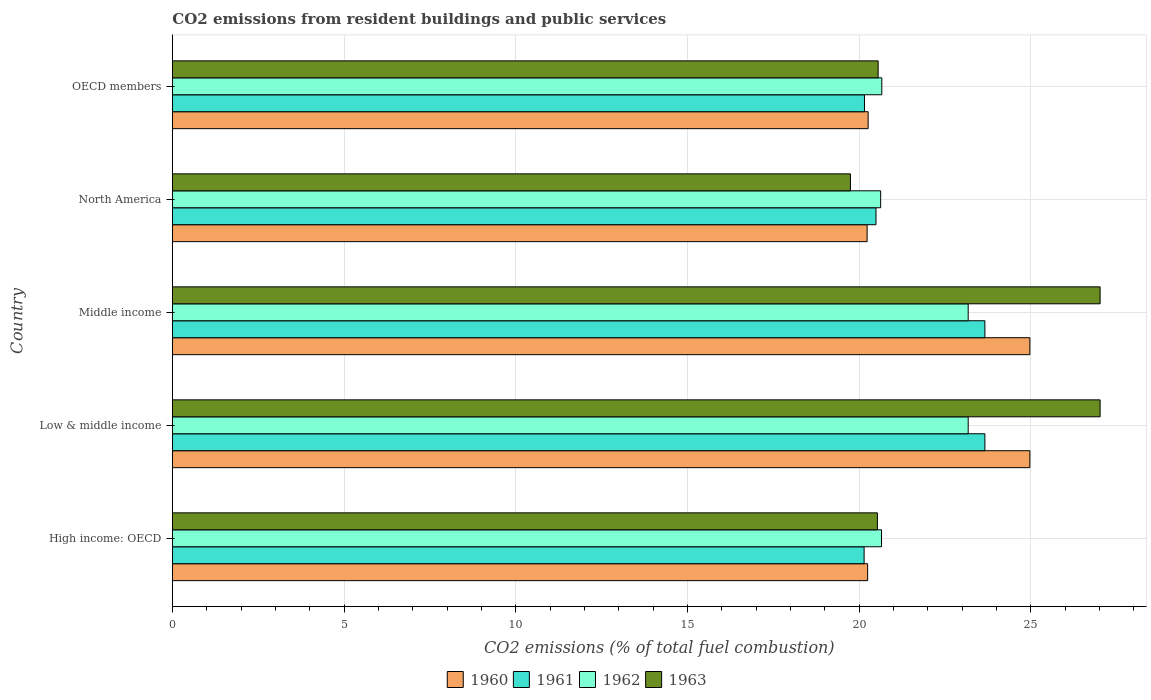Are the number of bars on each tick of the Y-axis equal?
Your answer should be compact. Yes. How many bars are there on the 5th tick from the top?
Offer a very short reply. 4. How many bars are there on the 1st tick from the bottom?
Your answer should be compact. 4. What is the total CO2 emitted in 1962 in OECD members?
Provide a succinct answer. 20.66. Across all countries, what is the maximum total CO2 emitted in 1962?
Provide a succinct answer. 23.17. Across all countries, what is the minimum total CO2 emitted in 1963?
Provide a short and direct response. 19.74. In which country was the total CO2 emitted in 1962 maximum?
Your answer should be compact. Low & middle income. What is the total total CO2 emitted in 1960 in the graph?
Provide a succinct answer. 110.68. What is the difference between the total CO2 emitted in 1962 in Low & middle income and that in North America?
Provide a short and direct response. 2.55. What is the difference between the total CO2 emitted in 1960 in High income: OECD and the total CO2 emitted in 1961 in Low & middle income?
Your response must be concise. -3.41. What is the average total CO2 emitted in 1963 per country?
Your answer should be compact. 22.97. What is the difference between the total CO2 emitted in 1963 and total CO2 emitted in 1960 in OECD members?
Give a very brief answer. 0.29. What is the ratio of the total CO2 emitted in 1961 in North America to that in OECD members?
Ensure brevity in your answer.  1.02. Is the total CO2 emitted in 1960 in High income: OECD less than that in Middle income?
Your response must be concise. Yes. What is the difference between the highest and the second highest total CO2 emitted in 1962?
Make the answer very short. 0. What is the difference between the highest and the lowest total CO2 emitted in 1961?
Your answer should be very brief. 3.52. In how many countries, is the total CO2 emitted in 1962 greater than the average total CO2 emitted in 1962 taken over all countries?
Provide a succinct answer. 2. What does the 1st bar from the top in OECD members represents?
Provide a succinct answer. 1963. How many bars are there?
Provide a short and direct response. 20. Are all the bars in the graph horizontal?
Your answer should be very brief. Yes. Are the values on the major ticks of X-axis written in scientific E-notation?
Make the answer very short. No. Does the graph contain any zero values?
Give a very brief answer. No. Where does the legend appear in the graph?
Your answer should be compact. Bottom center. How are the legend labels stacked?
Your answer should be very brief. Horizontal. What is the title of the graph?
Your answer should be very brief. CO2 emissions from resident buildings and public services. Does "1994" appear as one of the legend labels in the graph?
Offer a terse response. No. What is the label or title of the X-axis?
Your answer should be very brief. CO2 emissions (% of total fuel combustion). What is the label or title of the Y-axis?
Offer a terse response. Country. What is the CO2 emissions (% of total fuel combustion) in 1960 in High income: OECD?
Provide a short and direct response. 20.25. What is the CO2 emissions (% of total fuel combustion) of 1961 in High income: OECD?
Your answer should be very brief. 20.14. What is the CO2 emissions (% of total fuel combustion) of 1962 in High income: OECD?
Keep it short and to the point. 20.65. What is the CO2 emissions (% of total fuel combustion) of 1963 in High income: OECD?
Offer a very short reply. 20.53. What is the CO2 emissions (% of total fuel combustion) in 1960 in Low & middle income?
Make the answer very short. 24.97. What is the CO2 emissions (% of total fuel combustion) of 1961 in Low & middle income?
Your answer should be compact. 23.66. What is the CO2 emissions (% of total fuel combustion) of 1962 in Low & middle income?
Your response must be concise. 23.17. What is the CO2 emissions (% of total fuel combustion) of 1963 in Low & middle income?
Your response must be concise. 27.01. What is the CO2 emissions (% of total fuel combustion) of 1960 in Middle income?
Your answer should be compact. 24.97. What is the CO2 emissions (% of total fuel combustion) of 1961 in Middle income?
Your answer should be compact. 23.66. What is the CO2 emissions (% of total fuel combustion) of 1962 in Middle income?
Ensure brevity in your answer.  23.17. What is the CO2 emissions (% of total fuel combustion) of 1963 in Middle income?
Provide a succinct answer. 27.01. What is the CO2 emissions (% of total fuel combustion) of 1960 in North America?
Ensure brevity in your answer.  20.23. What is the CO2 emissions (% of total fuel combustion) in 1961 in North America?
Offer a terse response. 20.49. What is the CO2 emissions (% of total fuel combustion) of 1962 in North America?
Provide a short and direct response. 20.62. What is the CO2 emissions (% of total fuel combustion) in 1963 in North America?
Give a very brief answer. 19.74. What is the CO2 emissions (% of total fuel combustion) of 1960 in OECD members?
Make the answer very short. 20.26. What is the CO2 emissions (% of total fuel combustion) in 1961 in OECD members?
Your response must be concise. 20.15. What is the CO2 emissions (% of total fuel combustion) of 1962 in OECD members?
Your answer should be very brief. 20.66. What is the CO2 emissions (% of total fuel combustion) of 1963 in OECD members?
Your response must be concise. 20.55. Across all countries, what is the maximum CO2 emissions (% of total fuel combustion) of 1960?
Your response must be concise. 24.97. Across all countries, what is the maximum CO2 emissions (% of total fuel combustion) of 1961?
Provide a short and direct response. 23.66. Across all countries, what is the maximum CO2 emissions (% of total fuel combustion) of 1962?
Your response must be concise. 23.17. Across all countries, what is the maximum CO2 emissions (% of total fuel combustion) of 1963?
Your response must be concise. 27.01. Across all countries, what is the minimum CO2 emissions (% of total fuel combustion) in 1960?
Provide a succinct answer. 20.23. Across all countries, what is the minimum CO2 emissions (% of total fuel combustion) of 1961?
Your answer should be compact. 20.14. Across all countries, what is the minimum CO2 emissions (% of total fuel combustion) in 1962?
Ensure brevity in your answer.  20.62. Across all countries, what is the minimum CO2 emissions (% of total fuel combustion) of 1963?
Your answer should be very brief. 19.74. What is the total CO2 emissions (% of total fuel combustion) of 1960 in the graph?
Provide a succinct answer. 110.68. What is the total CO2 emissions (% of total fuel combustion) in 1961 in the graph?
Your answer should be compact. 108.11. What is the total CO2 emissions (% of total fuel combustion) in 1962 in the graph?
Make the answer very short. 108.28. What is the total CO2 emissions (% of total fuel combustion) in 1963 in the graph?
Your answer should be very brief. 114.86. What is the difference between the CO2 emissions (% of total fuel combustion) in 1960 in High income: OECD and that in Low & middle income?
Offer a terse response. -4.72. What is the difference between the CO2 emissions (% of total fuel combustion) in 1961 in High income: OECD and that in Low & middle income?
Your response must be concise. -3.52. What is the difference between the CO2 emissions (% of total fuel combustion) in 1962 in High income: OECD and that in Low & middle income?
Give a very brief answer. -2.52. What is the difference between the CO2 emissions (% of total fuel combustion) of 1963 in High income: OECD and that in Low & middle income?
Provide a succinct answer. -6.48. What is the difference between the CO2 emissions (% of total fuel combustion) in 1960 in High income: OECD and that in Middle income?
Make the answer very short. -4.72. What is the difference between the CO2 emissions (% of total fuel combustion) in 1961 in High income: OECD and that in Middle income?
Offer a terse response. -3.52. What is the difference between the CO2 emissions (% of total fuel combustion) in 1962 in High income: OECD and that in Middle income?
Ensure brevity in your answer.  -2.52. What is the difference between the CO2 emissions (% of total fuel combustion) of 1963 in High income: OECD and that in Middle income?
Offer a terse response. -6.48. What is the difference between the CO2 emissions (% of total fuel combustion) of 1960 in High income: OECD and that in North America?
Ensure brevity in your answer.  0.01. What is the difference between the CO2 emissions (% of total fuel combustion) in 1961 in High income: OECD and that in North America?
Provide a succinct answer. -0.35. What is the difference between the CO2 emissions (% of total fuel combustion) of 1962 in High income: OECD and that in North America?
Make the answer very short. 0.03. What is the difference between the CO2 emissions (% of total fuel combustion) in 1963 in High income: OECD and that in North America?
Offer a very short reply. 0.79. What is the difference between the CO2 emissions (% of total fuel combustion) of 1960 in High income: OECD and that in OECD members?
Your answer should be very brief. -0.01. What is the difference between the CO2 emissions (% of total fuel combustion) in 1961 in High income: OECD and that in OECD members?
Your answer should be very brief. -0.01. What is the difference between the CO2 emissions (% of total fuel combustion) in 1962 in High income: OECD and that in OECD members?
Keep it short and to the point. -0.01. What is the difference between the CO2 emissions (% of total fuel combustion) of 1963 in High income: OECD and that in OECD members?
Offer a terse response. -0.02. What is the difference between the CO2 emissions (% of total fuel combustion) in 1961 in Low & middle income and that in Middle income?
Ensure brevity in your answer.  0. What is the difference between the CO2 emissions (% of total fuel combustion) of 1962 in Low & middle income and that in Middle income?
Provide a short and direct response. 0. What is the difference between the CO2 emissions (% of total fuel combustion) in 1963 in Low & middle income and that in Middle income?
Offer a very short reply. 0. What is the difference between the CO2 emissions (% of total fuel combustion) of 1960 in Low & middle income and that in North America?
Offer a terse response. 4.74. What is the difference between the CO2 emissions (% of total fuel combustion) in 1961 in Low & middle income and that in North America?
Offer a terse response. 3.17. What is the difference between the CO2 emissions (% of total fuel combustion) in 1962 in Low & middle income and that in North America?
Offer a terse response. 2.55. What is the difference between the CO2 emissions (% of total fuel combustion) in 1963 in Low & middle income and that in North America?
Offer a very short reply. 7.27. What is the difference between the CO2 emissions (% of total fuel combustion) in 1960 in Low & middle income and that in OECD members?
Make the answer very short. 4.71. What is the difference between the CO2 emissions (% of total fuel combustion) of 1961 in Low & middle income and that in OECD members?
Your answer should be compact. 3.51. What is the difference between the CO2 emissions (% of total fuel combustion) of 1962 in Low & middle income and that in OECD members?
Offer a very short reply. 2.52. What is the difference between the CO2 emissions (% of total fuel combustion) of 1963 in Low & middle income and that in OECD members?
Offer a terse response. 6.46. What is the difference between the CO2 emissions (% of total fuel combustion) in 1960 in Middle income and that in North America?
Ensure brevity in your answer.  4.74. What is the difference between the CO2 emissions (% of total fuel combustion) in 1961 in Middle income and that in North America?
Make the answer very short. 3.17. What is the difference between the CO2 emissions (% of total fuel combustion) of 1962 in Middle income and that in North America?
Keep it short and to the point. 2.55. What is the difference between the CO2 emissions (% of total fuel combustion) of 1963 in Middle income and that in North America?
Give a very brief answer. 7.27. What is the difference between the CO2 emissions (% of total fuel combustion) of 1960 in Middle income and that in OECD members?
Your answer should be compact. 4.71. What is the difference between the CO2 emissions (% of total fuel combustion) in 1961 in Middle income and that in OECD members?
Keep it short and to the point. 3.51. What is the difference between the CO2 emissions (% of total fuel combustion) in 1962 in Middle income and that in OECD members?
Your answer should be compact. 2.52. What is the difference between the CO2 emissions (% of total fuel combustion) in 1963 in Middle income and that in OECD members?
Keep it short and to the point. 6.46. What is the difference between the CO2 emissions (% of total fuel combustion) of 1960 in North America and that in OECD members?
Ensure brevity in your answer.  -0.03. What is the difference between the CO2 emissions (% of total fuel combustion) of 1961 in North America and that in OECD members?
Your answer should be very brief. 0.34. What is the difference between the CO2 emissions (% of total fuel combustion) of 1962 in North America and that in OECD members?
Your answer should be compact. -0.03. What is the difference between the CO2 emissions (% of total fuel combustion) in 1963 in North America and that in OECD members?
Provide a short and direct response. -0.81. What is the difference between the CO2 emissions (% of total fuel combustion) of 1960 in High income: OECD and the CO2 emissions (% of total fuel combustion) of 1961 in Low & middle income?
Provide a succinct answer. -3.41. What is the difference between the CO2 emissions (% of total fuel combustion) of 1960 in High income: OECD and the CO2 emissions (% of total fuel combustion) of 1962 in Low & middle income?
Give a very brief answer. -2.93. What is the difference between the CO2 emissions (% of total fuel combustion) in 1960 in High income: OECD and the CO2 emissions (% of total fuel combustion) in 1963 in Low & middle income?
Your response must be concise. -6.77. What is the difference between the CO2 emissions (% of total fuel combustion) of 1961 in High income: OECD and the CO2 emissions (% of total fuel combustion) of 1962 in Low & middle income?
Provide a short and direct response. -3.03. What is the difference between the CO2 emissions (% of total fuel combustion) of 1961 in High income: OECD and the CO2 emissions (% of total fuel combustion) of 1963 in Low & middle income?
Your answer should be very brief. -6.87. What is the difference between the CO2 emissions (% of total fuel combustion) of 1962 in High income: OECD and the CO2 emissions (% of total fuel combustion) of 1963 in Low & middle income?
Your answer should be compact. -6.36. What is the difference between the CO2 emissions (% of total fuel combustion) in 1960 in High income: OECD and the CO2 emissions (% of total fuel combustion) in 1961 in Middle income?
Offer a terse response. -3.41. What is the difference between the CO2 emissions (% of total fuel combustion) of 1960 in High income: OECD and the CO2 emissions (% of total fuel combustion) of 1962 in Middle income?
Ensure brevity in your answer.  -2.93. What is the difference between the CO2 emissions (% of total fuel combustion) in 1960 in High income: OECD and the CO2 emissions (% of total fuel combustion) in 1963 in Middle income?
Offer a very short reply. -6.77. What is the difference between the CO2 emissions (% of total fuel combustion) of 1961 in High income: OECD and the CO2 emissions (% of total fuel combustion) of 1962 in Middle income?
Your response must be concise. -3.03. What is the difference between the CO2 emissions (% of total fuel combustion) in 1961 in High income: OECD and the CO2 emissions (% of total fuel combustion) in 1963 in Middle income?
Offer a terse response. -6.87. What is the difference between the CO2 emissions (% of total fuel combustion) of 1962 in High income: OECD and the CO2 emissions (% of total fuel combustion) of 1963 in Middle income?
Your response must be concise. -6.36. What is the difference between the CO2 emissions (% of total fuel combustion) of 1960 in High income: OECD and the CO2 emissions (% of total fuel combustion) of 1961 in North America?
Give a very brief answer. -0.24. What is the difference between the CO2 emissions (% of total fuel combustion) of 1960 in High income: OECD and the CO2 emissions (% of total fuel combustion) of 1962 in North America?
Your answer should be very brief. -0.38. What is the difference between the CO2 emissions (% of total fuel combustion) of 1960 in High income: OECD and the CO2 emissions (% of total fuel combustion) of 1963 in North America?
Offer a terse response. 0.5. What is the difference between the CO2 emissions (% of total fuel combustion) in 1961 in High income: OECD and the CO2 emissions (% of total fuel combustion) in 1962 in North America?
Ensure brevity in your answer.  -0.48. What is the difference between the CO2 emissions (% of total fuel combustion) of 1961 in High income: OECD and the CO2 emissions (% of total fuel combustion) of 1963 in North America?
Provide a short and direct response. 0.4. What is the difference between the CO2 emissions (% of total fuel combustion) in 1962 in High income: OECD and the CO2 emissions (% of total fuel combustion) in 1963 in North America?
Your answer should be compact. 0.91. What is the difference between the CO2 emissions (% of total fuel combustion) in 1960 in High income: OECD and the CO2 emissions (% of total fuel combustion) in 1961 in OECD members?
Provide a succinct answer. 0.09. What is the difference between the CO2 emissions (% of total fuel combustion) in 1960 in High income: OECD and the CO2 emissions (% of total fuel combustion) in 1962 in OECD members?
Offer a very short reply. -0.41. What is the difference between the CO2 emissions (% of total fuel combustion) of 1960 in High income: OECD and the CO2 emissions (% of total fuel combustion) of 1963 in OECD members?
Offer a very short reply. -0.31. What is the difference between the CO2 emissions (% of total fuel combustion) of 1961 in High income: OECD and the CO2 emissions (% of total fuel combustion) of 1962 in OECD members?
Provide a succinct answer. -0.52. What is the difference between the CO2 emissions (% of total fuel combustion) in 1961 in High income: OECD and the CO2 emissions (% of total fuel combustion) in 1963 in OECD members?
Provide a short and direct response. -0.41. What is the difference between the CO2 emissions (% of total fuel combustion) of 1962 in High income: OECD and the CO2 emissions (% of total fuel combustion) of 1963 in OECD members?
Provide a succinct answer. 0.1. What is the difference between the CO2 emissions (% of total fuel combustion) of 1960 in Low & middle income and the CO2 emissions (% of total fuel combustion) of 1961 in Middle income?
Provide a short and direct response. 1.31. What is the difference between the CO2 emissions (% of total fuel combustion) of 1960 in Low & middle income and the CO2 emissions (% of total fuel combustion) of 1962 in Middle income?
Make the answer very short. 1.8. What is the difference between the CO2 emissions (% of total fuel combustion) in 1960 in Low & middle income and the CO2 emissions (% of total fuel combustion) in 1963 in Middle income?
Offer a very short reply. -2.05. What is the difference between the CO2 emissions (% of total fuel combustion) of 1961 in Low & middle income and the CO2 emissions (% of total fuel combustion) of 1962 in Middle income?
Your answer should be compact. 0.49. What is the difference between the CO2 emissions (% of total fuel combustion) in 1961 in Low & middle income and the CO2 emissions (% of total fuel combustion) in 1963 in Middle income?
Provide a short and direct response. -3.35. What is the difference between the CO2 emissions (% of total fuel combustion) of 1962 in Low & middle income and the CO2 emissions (% of total fuel combustion) of 1963 in Middle income?
Your answer should be compact. -3.84. What is the difference between the CO2 emissions (% of total fuel combustion) in 1960 in Low & middle income and the CO2 emissions (% of total fuel combustion) in 1961 in North America?
Your answer should be very brief. 4.48. What is the difference between the CO2 emissions (% of total fuel combustion) in 1960 in Low & middle income and the CO2 emissions (% of total fuel combustion) in 1962 in North America?
Your answer should be very brief. 4.35. What is the difference between the CO2 emissions (% of total fuel combustion) of 1960 in Low & middle income and the CO2 emissions (% of total fuel combustion) of 1963 in North America?
Provide a succinct answer. 5.22. What is the difference between the CO2 emissions (% of total fuel combustion) in 1961 in Low & middle income and the CO2 emissions (% of total fuel combustion) in 1962 in North America?
Offer a very short reply. 3.04. What is the difference between the CO2 emissions (% of total fuel combustion) in 1961 in Low & middle income and the CO2 emissions (% of total fuel combustion) in 1963 in North America?
Keep it short and to the point. 3.92. What is the difference between the CO2 emissions (% of total fuel combustion) of 1962 in Low & middle income and the CO2 emissions (% of total fuel combustion) of 1963 in North America?
Your answer should be compact. 3.43. What is the difference between the CO2 emissions (% of total fuel combustion) in 1960 in Low & middle income and the CO2 emissions (% of total fuel combustion) in 1961 in OECD members?
Your answer should be compact. 4.82. What is the difference between the CO2 emissions (% of total fuel combustion) of 1960 in Low & middle income and the CO2 emissions (% of total fuel combustion) of 1962 in OECD members?
Make the answer very short. 4.31. What is the difference between the CO2 emissions (% of total fuel combustion) of 1960 in Low & middle income and the CO2 emissions (% of total fuel combustion) of 1963 in OECD members?
Keep it short and to the point. 4.42. What is the difference between the CO2 emissions (% of total fuel combustion) of 1961 in Low & middle income and the CO2 emissions (% of total fuel combustion) of 1962 in OECD members?
Offer a very short reply. 3. What is the difference between the CO2 emissions (% of total fuel combustion) of 1961 in Low & middle income and the CO2 emissions (% of total fuel combustion) of 1963 in OECD members?
Your response must be concise. 3.11. What is the difference between the CO2 emissions (% of total fuel combustion) in 1962 in Low & middle income and the CO2 emissions (% of total fuel combustion) in 1963 in OECD members?
Keep it short and to the point. 2.62. What is the difference between the CO2 emissions (% of total fuel combustion) of 1960 in Middle income and the CO2 emissions (% of total fuel combustion) of 1961 in North America?
Provide a short and direct response. 4.48. What is the difference between the CO2 emissions (% of total fuel combustion) in 1960 in Middle income and the CO2 emissions (% of total fuel combustion) in 1962 in North America?
Provide a short and direct response. 4.35. What is the difference between the CO2 emissions (% of total fuel combustion) of 1960 in Middle income and the CO2 emissions (% of total fuel combustion) of 1963 in North America?
Your answer should be very brief. 5.22. What is the difference between the CO2 emissions (% of total fuel combustion) in 1961 in Middle income and the CO2 emissions (% of total fuel combustion) in 1962 in North America?
Make the answer very short. 3.04. What is the difference between the CO2 emissions (% of total fuel combustion) of 1961 in Middle income and the CO2 emissions (% of total fuel combustion) of 1963 in North America?
Your response must be concise. 3.92. What is the difference between the CO2 emissions (% of total fuel combustion) in 1962 in Middle income and the CO2 emissions (% of total fuel combustion) in 1963 in North America?
Your answer should be compact. 3.43. What is the difference between the CO2 emissions (% of total fuel combustion) of 1960 in Middle income and the CO2 emissions (% of total fuel combustion) of 1961 in OECD members?
Keep it short and to the point. 4.82. What is the difference between the CO2 emissions (% of total fuel combustion) in 1960 in Middle income and the CO2 emissions (% of total fuel combustion) in 1962 in OECD members?
Your response must be concise. 4.31. What is the difference between the CO2 emissions (% of total fuel combustion) of 1960 in Middle income and the CO2 emissions (% of total fuel combustion) of 1963 in OECD members?
Provide a short and direct response. 4.42. What is the difference between the CO2 emissions (% of total fuel combustion) in 1961 in Middle income and the CO2 emissions (% of total fuel combustion) in 1962 in OECD members?
Provide a short and direct response. 3. What is the difference between the CO2 emissions (% of total fuel combustion) in 1961 in Middle income and the CO2 emissions (% of total fuel combustion) in 1963 in OECD members?
Make the answer very short. 3.11. What is the difference between the CO2 emissions (% of total fuel combustion) of 1962 in Middle income and the CO2 emissions (% of total fuel combustion) of 1963 in OECD members?
Give a very brief answer. 2.62. What is the difference between the CO2 emissions (% of total fuel combustion) of 1960 in North America and the CO2 emissions (% of total fuel combustion) of 1961 in OECD members?
Ensure brevity in your answer.  0.08. What is the difference between the CO2 emissions (% of total fuel combustion) in 1960 in North America and the CO2 emissions (% of total fuel combustion) in 1962 in OECD members?
Provide a succinct answer. -0.43. What is the difference between the CO2 emissions (% of total fuel combustion) in 1960 in North America and the CO2 emissions (% of total fuel combustion) in 1963 in OECD members?
Ensure brevity in your answer.  -0.32. What is the difference between the CO2 emissions (% of total fuel combustion) in 1961 in North America and the CO2 emissions (% of total fuel combustion) in 1962 in OECD members?
Provide a short and direct response. -0.17. What is the difference between the CO2 emissions (% of total fuel combustion) in 1961 in North America and the CO2 emissions (% of total fuel combustion) in 1963 in OECD members?
Offer a terse response. -0.06. What is the difference between the CO2 emissions (% of total fuel combustion) in 1962 in North America and the CO2 emissions (% of total fuel combustion) in 1963 in OECD members?
Make the answer very short. 0.07. What is the average CO2 emissions (% of total fuel combustion) in 1960 per country?
Keep it short and to the point. 22.14. What is the average CO2 emissions (% of total fuel combustion) in 1961 per country?
Provide a short and direct response. 21.62. What is the average CO2 emissions (% of total fuel combustion) in 1962 per country?
Make the answer very short. 21.66. What is the average CO2 emissions (% of total fuel combustion) in 1963 per country?
Provide a short and direct response. 22.97. What is the difference between the CO2 emissions (% of total fuel combustion) of 1960 and CO2 emissions (% of total fuel combustion) of 1961 in High income: OECD?
Your response must be concise. 0.1. What is the difference between the CO2 emissions (% of total fuel combustion) in 1960 and CO2 emissions (% of total fuel combustion) in 1962 in High income: OECD?
Keep it short and to the point. -0.4. What is the difference between the CO2 emissions (% of total fuel combustion) in 1960 and CO2 emissions (% of total fuel combustion) in 1963 in High income: OECD?
Keep it short and to the point. -0.28. What is the difference between the CO2 emissions (% of total fuel combustion) of 1961 and CO2 emissions (% of total fuel combustion) of 1962 in High income: OECD?
Provide a succinct answer. -0.51. What is the difference between the CO2 emissions (% of total fuel combustion) in 1961 and CO2 emissions (% of total fuel combustion) in 1963 in High income: OECD?
Offer a very short reply. -0.39. What is the difference between the CO2 emissions (% of total fuel combustion) in 1962 and CO2 emissions (% of total fuel combustion) in 1963 in High income: OECD?
Your response must be concise. 0.12. What is the difference between the CO2 emissions (% of total fuel combustion) in 1960 and CO2 emissions (% of total fuel combustion) in 1961 in Low & middle income?
Provide a succinct answer. 1.31. What is the difference between the CO2 emissions (% of total fuel combustion) of 1960 and CO2 emissions (% of total fuel combustion) of 1962 in Low & middle income?
Keep it short and to the point. 1.8. What is the difference between the CO2 emissions (% of total fuel combustion) in 1960 and CO2 emissions (% of total fuel combustion) in 1963 in Low & middle income?
Ensure brevity in your answer.  -2.05. What is the difference between the CO2 emissions (% of total fuel combustion) in 1961 and CO2 emissions (% of total fuel combustion) in 1962 in Low & middle income?
Your answer should be very brief. 0.49. What is the difference between the CO2 emissions (% of total fuel combustion) of 1961 and CO2 emissions (% of total fuel combustion) of 1963 in Low & middle income?
Offer a terse response. -3.35. What is the difference between the CO2 emissions (% of total fuel combustion) in 1962 and CO2 emissions (% of total fuel combustion) in 1963 in Low & middle income?
Your response must be concise. -3.84. What is the difference between the CO2 emissions (% of total fuel combustion) of 1960 and CO2 emissions (% of total fuel combustion) of 1961 in Middle income?
Give a very brief answer. 1.31. What is the difference between the CO2 emissions (% of total fuel combustion) in 1960 and CO2 emissions (% of total fuel combustion) in 1962 in Middle income?
Make the answer very short. 1.8. What is the difference between the CO2 emissions (% of total fuel combustion) of 1960 and CO2 emissions (% of total fuel combustion) of 1963 in Middle income?
Make the answer very short. -2.05. What is the difference between the CO2 emissions (% of total fuel combustion) of 1961 and CO2 emissions (% of total fuel combustion) of 1962 in Middle income?
Provide a succinct answer. 0.49. What is the difference between the CO2 emissions (% of total fuel combustion) of 1961 and CO2 emissions (% of total fuel combustion) of 1963 in Middle income?
Offer a terse response. -3.35. What is the difference between the CO2 emissions (% of total fuel combustion) of 1962 and CO2 emissions (% of total fuel combustion) of 1963 in Middle income?
Make the answer very short. -3.84. What is the difference between the CO2 emissions (% of total fuel combustion) of 1960 and CO2 emissions (% of total fuel combustion) of 1961 in North America?
Provide a succinct answer. -0.26. What is the difference between the CO2 emissions (% of total fuel combustion) in 1960 and CO2 emissions (% of total fuel combustion) in 1962 in North America?
Provide a succinct answer. -0.39. What is the difference between the CO2 emissions (% of total fuel combustion) of 1960 and CO2 emissions (% of total fuel combustion) of 1963 in North America?
Offer a terse response. 0.49. What is the difference between the CO2 emissions (% of total fuel combustion) in 1961 and CO2 emissions (% of total fuel combustion) in 1962 in North America?
Ensure brevity in your answer.  -0.14. What is the difference between the CO2 emissions (% of total fuel combustion) in 1961 and CO2 emissions (% of total fuel combustion) in 1963 in North America?
Ensure brevity in your answer.  0.74. What is the difference between the CO2 emissions (% of total fuel combustion) in 1962 and CO2 emissions (% of total fuel combustion) in 1963 in North America?
Make the answer very short. 0.88. What is the difference between the CO2 emissions (% of total fuel combustion) of 1960 and CO2 emissions (% of total fuel combustion) of 1961 in OECD members?
Your answer should be very brief. 0.11. What is the difference between the CO2 emissions (% of total fuel combustion) in 1960 and CO2 emissions (% of total fuel combustion) in 1962 in OECD members?
Ensure brevity in your answer.  -0.4. What is the difference between the CO2 emissions (% of total fuel combustion) in 1960 and CO2 emissions (% of total fuel combustion) in 1963 in OECD members?
Make the answer very short. -0.29. What is the difference between the CO2 emissions (% of total fuel combustion) of 1961 and CO2 emissions (% of total fuel combustion) of 1962 in OECD members?
Your answer should be very brief. -0.5. What is the difference between the CO2 emissions (% of total fuel combustion) of 1961 and CO2 emissions (% of total fuel combustion) of 1963 in OECD members?
Provide a short and direct response. -0.4. What is the difference between the CO2 emissions (% of total fuel combustion) of 1962 and CO2 emissions (% of total fuel combustion) of 1963 in OECD members?
Your answer should be compact. 0.11. What is the ratio of the CO2 emissions (% of total fuel combustion) in 1960 in High income: OECD to that in Low & middle income?
Offer a very short reply. 0.81. What is the ratio of the CO2 emissions (% of total fuel combustion) of 1961 in High income: OECD to that in Low & middle income?
Your answer should be compact. 0.85. What is the ratio of the CO2 emissions (% of total fuel combustion) of 1962 in High income: OECD to that in Low & middle income?
Provide a short and direct response. 0.89. What is the ratio of the CO2 emissions (% of total fuel combustion) in 1963 in High income: OECD to that in Low & middle income?
Your answer should be very brief. 0.76. What is the ratio of the CO2 emissions (% of total fuel combustion) in 1960 in High income: OECD to that in Middle income?
Offer a terse response. 0.81. What is the ratio of the CO2 emissions (% of total fuel combustion) of 1961 in High income: OECD to that in Middle income?
Your answer should be compact. 0.85. What is the ratio of the CO2 emissions (% of total fuel combustion) in 1962 in High income: OECD to that in Middle income?
Provide a short and direct response. 0.89. What is the ratio of the CO2 emissions (% of total fuel combustion) of 1963 in High income: OECD to that in Middle income?
Your answer should be very brief. 0.76. What is the ratio of the CO2 emissions (% of total fuel combustion) of 1961 in High income: OECD to that in North America?
Your answer should be compact. 0.98. What is the ratio of the CO2 emissions (% of total fuel combustion) in 1963 in High income: OECD to that in North America?
Offer a terse response. 1.04. What is the ratio of the CO2 emissions (% of total fuel combustion) of 1960 in High income: OECD to that in OECD members?
Offer a terse response. 1. What is the ratio of the CO2 emissions (% of total fuel combustion) in 1961 in High income: OECD to that in OECD members?
Ensure brevity in your answer.  1. What is the ratio of the CO2 emissions (% of total fuel combustion) of 1962 in High income: OECD to that in OECD members?
Give a very brief answer. 1. What is the ratio of the CO2 emissions (% of total fuel combustion) in 1963 in High income: OECD to that in OECD members?
Your answer should be very brief. 1. What is the ratio of the CO2 emissions (% of total fuel combustion) in 1960 in Low & middle income to that in North America?
Provide a short and direct response. 1.23. What is the ratio of the CO2 emissions (% of total fuel combustion) of 1961 in Low & middle income to that in North America?
Provide a short and direct response. 1.15. What is the ratio of the CO2 emissions (% of total fuel combustion) in 1962 in Low & middle income to that in North America?
Your response must be concise. 1.12. What is the ratio of the CO2 emissions (% of total fuel combustion) in 1963 in Low & middle income to that in North America?
Your answer should be very brief. 1.37. What is the ratio of the CO2 emissions (% of total fuel combustion) in 1960 in Low & middle income to that in OECD members?
Provide a short and direct response. 1.23. What is the ratio of the CO2 emissions (% of total fuel combustion) in 1961 in Low & middle income to that in OECD members?
Provide a short and direct response. 1.17. What is the ratio of the CO2 emissions (% of total fuel combustion) of 1962 in Low & middle income to that in OECD members?
Give a very brief answer. 1.12. What is the ratio of the CO2 emissions (% of total fuel combustion) of 1963 in Low & middle income to that in OECD members?
Keep it short and to the point. 1.31. What is the ratio of the CO2 emissions (% of total fuel combustion) in 1960 in Middle income to that in North America?
Offer a terse response. 1.23. What is the ratio of the CO2 emissions (% of total fuel combustion) of 1961 in Middle income to that in North America?
Make the answer very short. 1.15. What is the ratio of the CO2 emissions (% of total fuel combustion) in 1962 in Middle income to that in North America?
Make the answer very short. 1.12. What is the ratio of the CO2 emissions (% of total fuel combustion) of 1963 in Middle income to that in North America?
Ensure brevity in your answer.  1.37. What is the ratio of the CO2 emissions (% of total fuel combustion) in 1960 in Middle income to that in OECD members?
Keep it short and to the point. 1.23. What is the ratio of the CO2 emissions (% of total fuel combustion) of 1961 in Middle income to that in OECD members?
Ensure brevity in your answer.  1.17. What is the ratio of the CO2 emissions (% of total fuel combustion) of 1962 in Middle income to that in OECD members?
Keep it short and to the point. 1.12. What is the ratio of the CO2 emissions (% of total fuel combustion) in 1963 in Middle income to that in OECD members?
Offer a terse response. 1.31. What is the ratio of the CO2 emissions (% of total fuel combustion) of 1960 in North America to that in OECD members?
Your answer should be compact. 1. What is the ratio of the CO2 emissions (% of total fuel combustion) of 1961 in North America to that in OECD members?
Your response must be concise. 1.02. What is the ratio of the CO2 emissions (% of total fuel combustion) of 1963 in North America to that in OECD members?
Provide a succinct answer. 0.96. What is the difference between the highest and the second highest CO2 emissions (% of total fuel combustion) of 1961?
Give a very brief answer. 0. What is the difference between the highest and the second highest CO2 emissions (% of total fuel combustion) of 1962?
Give a very brief answer. 0. What is the difference between the highest and the lowest CO2 emissions (% of total fuel combustion) of 1960?
Provide a succinct answer. 4.74. What is the difference between the highest and the lowest CO2 emissions (% of total fuel combustion) in 1961?
Offer a very short reply. 3.52. What is the difference between the highest and the lowest CO2 emissions (% of total fuel combustion) of 1962?
Make the answer very short. 2.55. What is the difference between the highest and the lowest CO2 emissions (% of total fuel combustion) of 1963?
Provide a short and direct response. 7.27. 